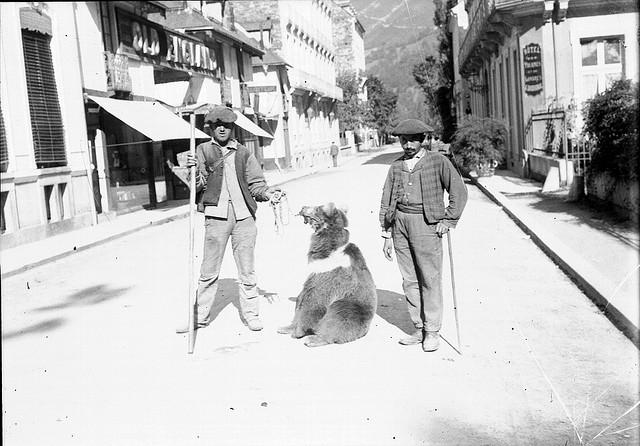Judging from the dress, was this taken in a Latin American country?
Short answer required. Yes. What colors are shown in this picture?
Quick response, please. Black and white. Are the men on the sidewalk?
Concise answer only. No. Was this photo taken recently?
Short answer required. No. 